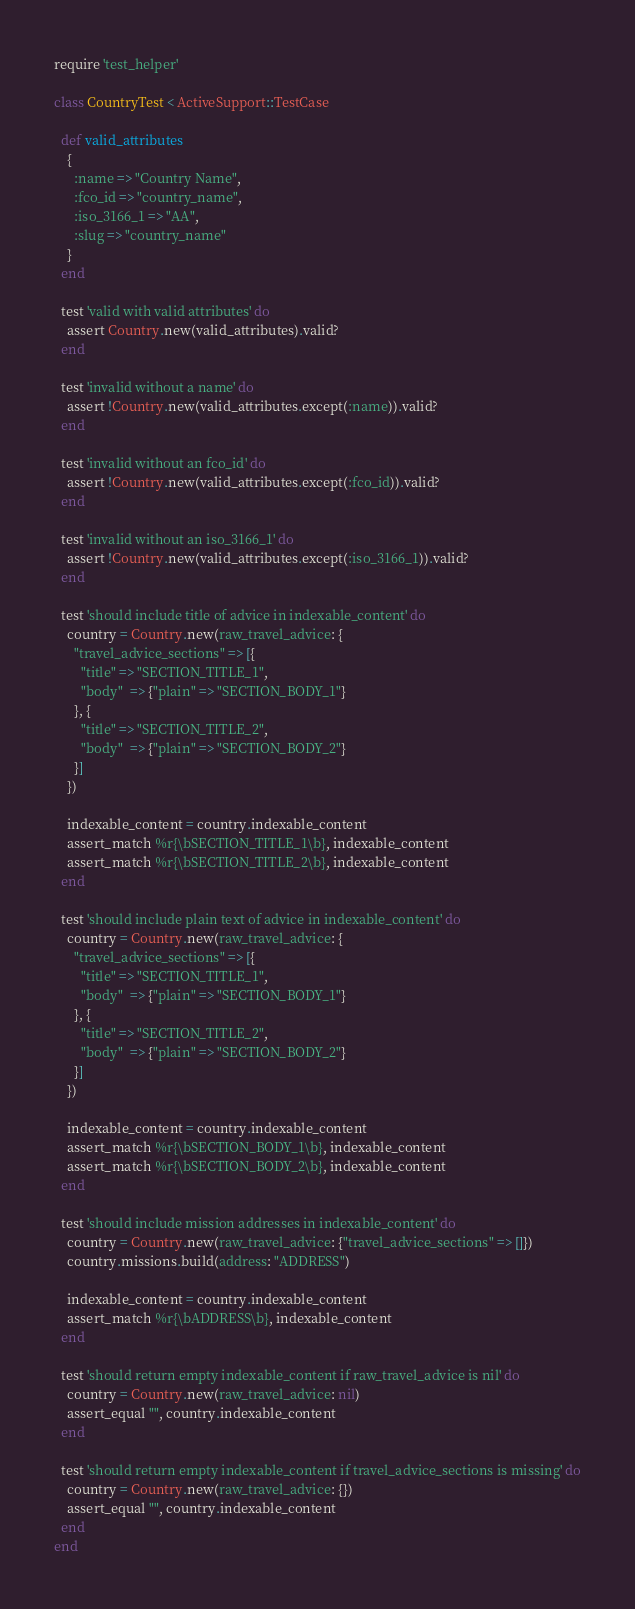<code> <loc_0><loc_0><loc_500><loc_500><_Ruby_>require 'test_helper'

class CountryTest < ActiveSupport::TestCase

  def valid_attributes
    {
      :name => "Country Name",
      :fco_id => "country_name",
      :iso_3166_1 => "AA",
      :slug => "country_name"
    }
  end

  test 'valid with valid attributes' do
    assert Country.new(valid_attributes).valid?
  end

  test 'invalid without a name' do
    assert !Country.new(valid_attributes.except(:name)).valid?
  end

  test 'invalid without an fco_id' do
    assert !Country.new(valid_attributes.except(:fco_id)).valid?
  end

  test 'invalid without an iso_3166_1' do
    assert !Country.new(valid_attributes.except(:iso_3166_1)).valid?
  end

  test 'should include title of advice in indexable_content' do
    country = Country.new(raw_travel_advice: {
      "travel_advice_sections" => [{
        "title" => "SECTION_TITLE_1",
        "body"  => {"plain" => "SECTION_BODY_1"}
      }, {
        "title" => "SECTION_TITLE_2",
        "body"  => {"plain" => "SECTION_BODY_2"}
      }]
    })

    indexable_content = country.indexable_content
    assert_match %r{\bSECTION_TITLE_1\b}, indexable_content
    assert_match %r{\bSECTION_TITLE_2\b}, indexable_content
  end

  test 'should include plain text of advice in indexable_content' do
    country = Country.new(raw_travel_advice: {
      "travel_advice_sections" => [{
        "title" => "SECTION_TITLE_1",
        "body"  => {"plain" => "SECTION_BODY_1"}
      }, {
        "title" => "SECTION_TITLE_2",
        "body"  => {"plain" => "SECTION_BODY_2"}
      }]
    })

    indexable_content = country.indexable_content
    assert_match %r{\bSECTION_BODY_1\b}, indexable_content
    assert_match %r{\bSECTION_BODY_2\b}, indexable_content
  end

  test 'should include mission addresses in indexable_content' do
    country = Country.new(raw_travel_advice: {"travel_advice_sections" => []})
    country.missions.build(address: "ADDRESS")

    indexable_content = country.indexable_content
    assert_match %r{\bADDRESS\b}, indexable_content
  end

  test 'should return empty indexable_content if raw_travel_advice is nil' do
    country = Country.new(raw_travel_advice: nil)
    assert_equal "", country.indexable_content
  end

  test 'should return empty indexable_content if travel_advice_sections is missing' do
    country = Country.new(raw_travel_advice: {})
    assert_equal "", country.indexable_content
  end
end
</code> 